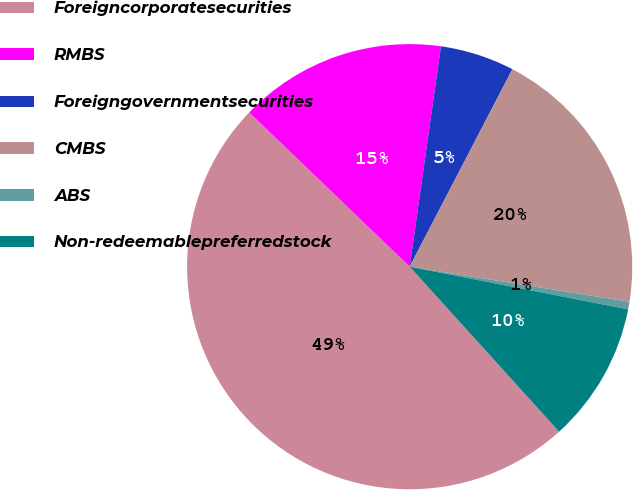Convert chart. <chart><loc_0><loc_0><loc_500><loc_500><pie_chart><fcel>Foreigncorporatesecurities<fcel>RMBS<fcel>Foreigngovernmentsecurities<fcel>CMBS<fcel>ABS<fcel>Non-redeemablepreferredstock<nl><fcel>48.9%<fcel>15.06%<fcel>5.39%<fcel>19.89%<fcel>0.55%<fcel>10.22%<nl></chart> 